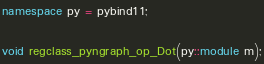Convert code to text. <code><loc_0><loc_0><loc_500><loc_500><_C++_>
namespace py = pybind11;

void regclass_pyngraph_op_Dot(py::module m);
</code> 